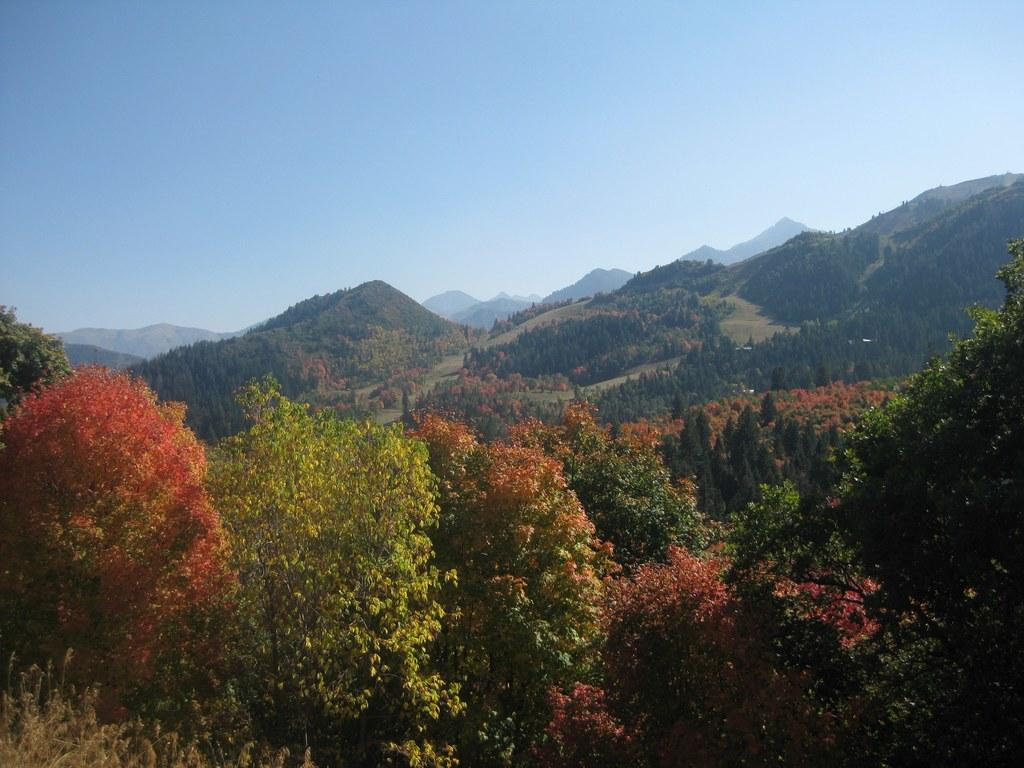Where was the image taken? The image was clicked outside. What geographical features can be seen in the image? There are mountains in the image. What type of vegetation is present in the image? There are plants in the image. What part of the natural environment is visible in the image? The sky is visible in the image. What type of prose is being written on the mountains in the image? There is no prose or writing visible on the mountains in the image. What color is the crayon used to draw the plants in the image? There is no crayon or drawing present in the image; the plants are real. 